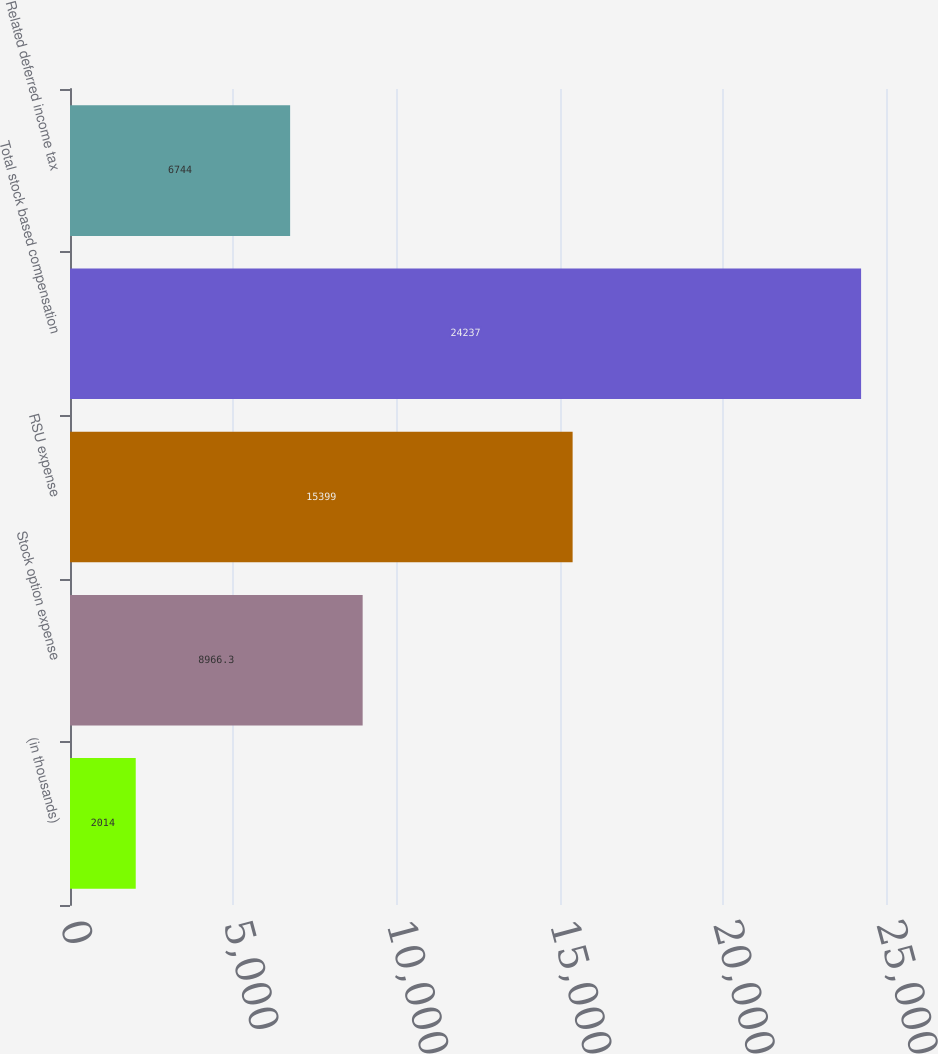Convert chart. <chart><loc_0><loc_0><loc_500><loc_500><bar_chart><fcel>(in thousands)<fcel>Stock option expense<fcel>RSU expense<fcel>Total stock based compensation<fcel>Related deferred income tax<nl><fcel>2014<fcel>8966.3<fcel>15399<fcel>24237<fcel>6744<nl></chart> 